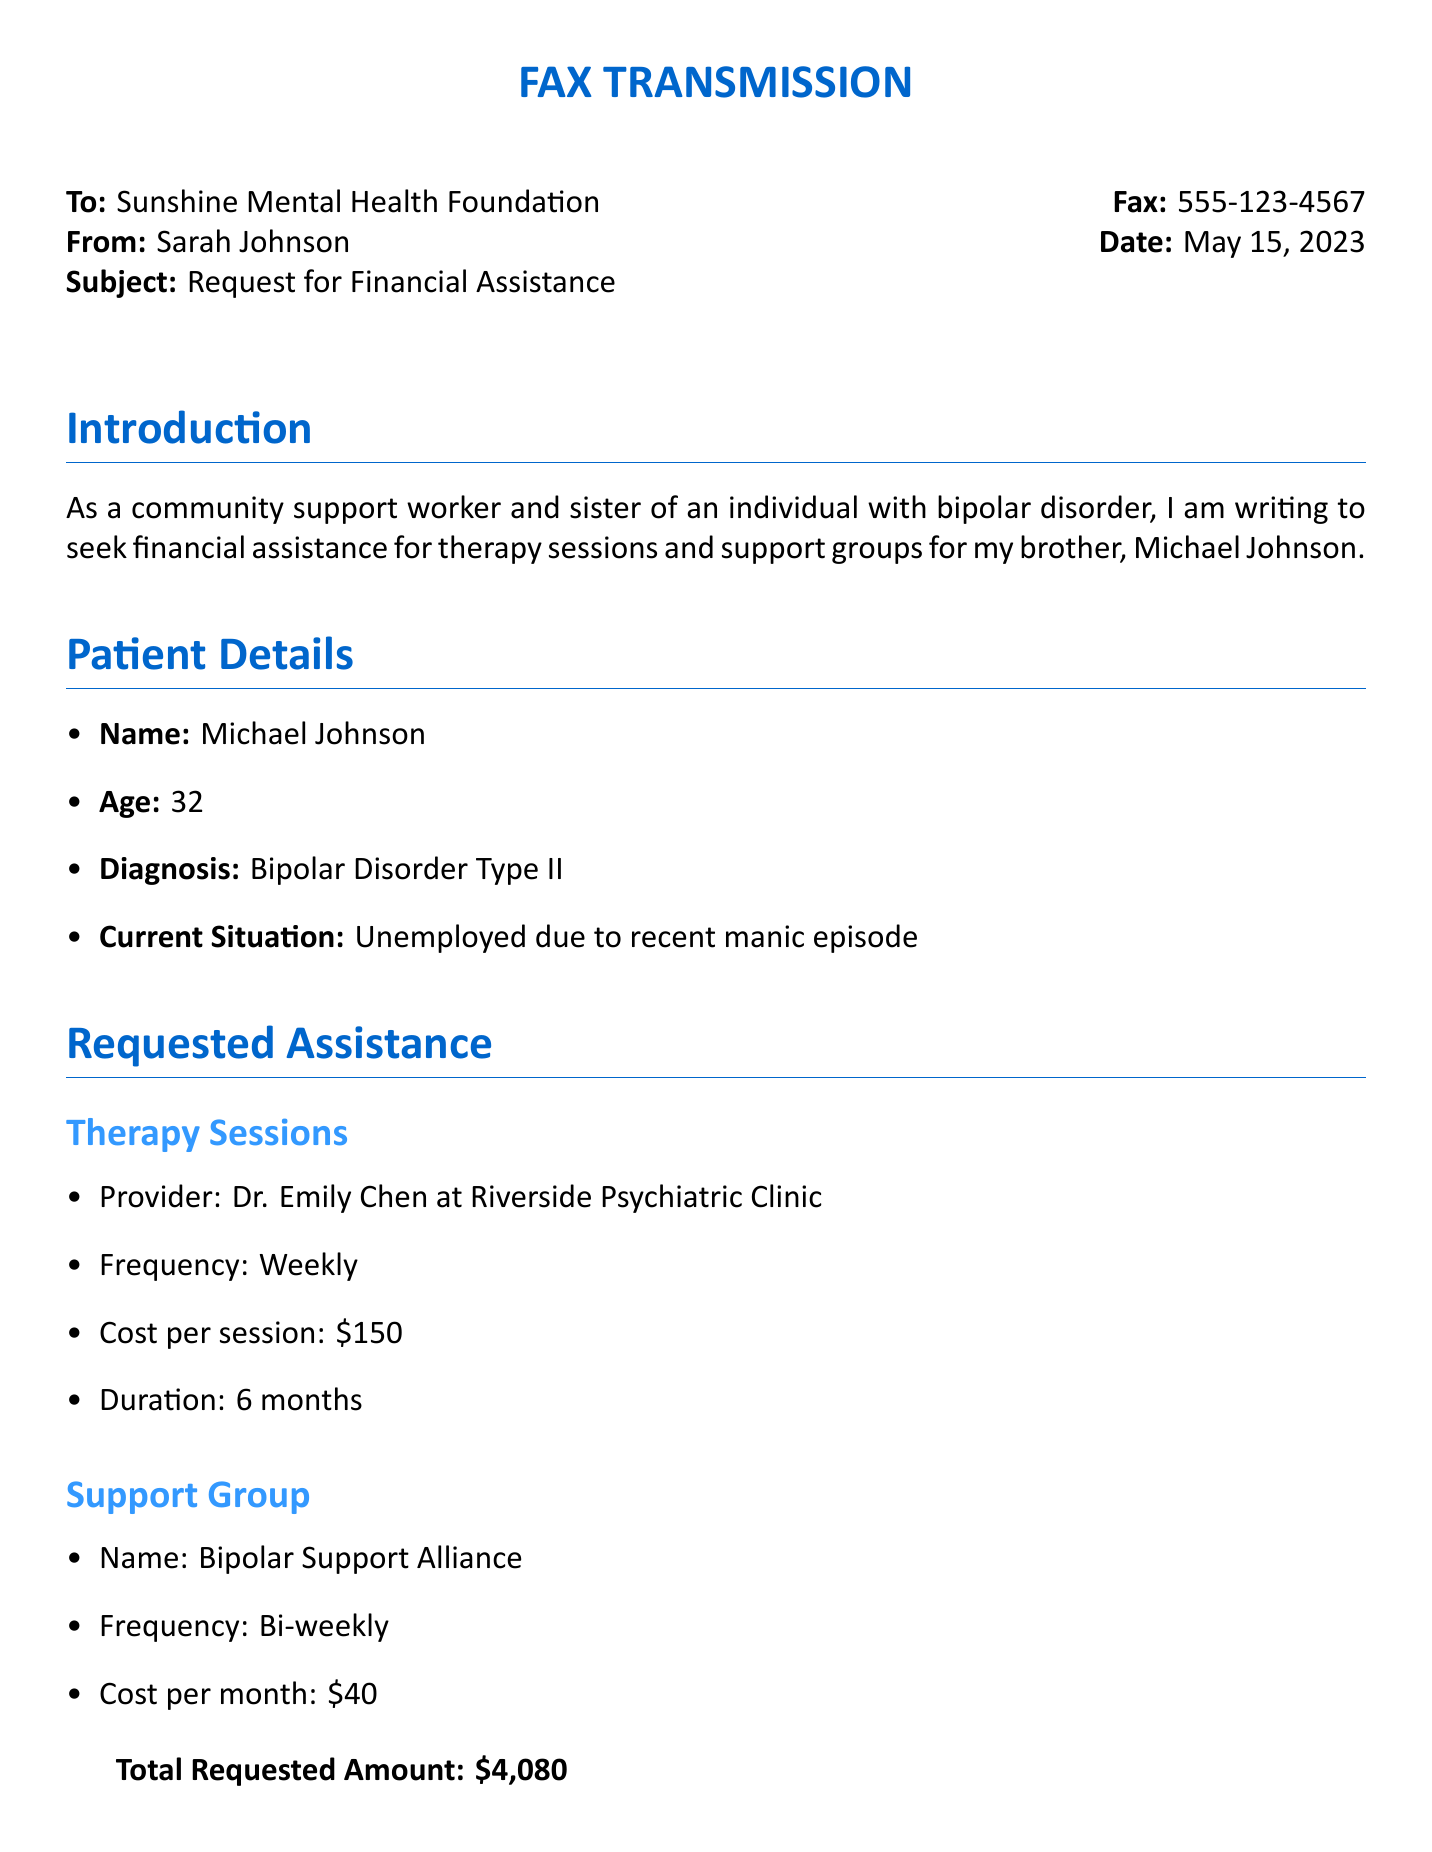What is the name of the patient? The patient's name is stated in the document under Patient Details.
Answer: Michael Johnson What is the diagnosis of Michael Johnson? The diagnosis is mentioned in the Patient Details section of the document.
Answer: Bipolar Disorder Type II Who is the therapy provider? The name of the therapy provider is provided in the Requested Assistance section under Therapy Sessions.
Answer: Dr. Emily Chen What is the cost per therapy session? The cost per session is specified in the Requested Assistance section for Therapy Sessions.
Answer: $150 How often does Michael attend therapy sessions? The frequency of therapy sessions is mentioned in the Requested Assistance section.
Answer: Weekly What is the name of the support group? The name of the support group is found in the Requested Assistance section under Support Group.
Answer: Bipolar Support Alliance What is the total requested amount for assistance? The total requested amount is indicated near the end of the Requested Assistance section.
Answer: $4,080 What is the frequency of the support group meetings? The frequency of meetings for the support group is provided in the document under Support Group.
Answer: Bi-weekly 